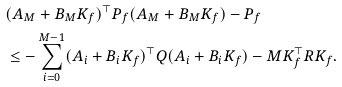Convert formula to latex. <formula><loc_0><loc_0><loc_500><loc_500>& ( A _ { M } + B _ { M } K _ { f } ) ^ { \top } P _ { f } ( A _ { M } + B _ { M } K _ { f } ) - P _ { f } \\ & \leq - \sum _ { i = 0 } ^ { M - 1 } ( A _ { i } + B _ { i } K _ { f } ) ^ { \top } Q ( A _ { i } + B _ { i } K _ { f } ) - M K _ { f } ^ { \top } R K _ { f } .</formula> 